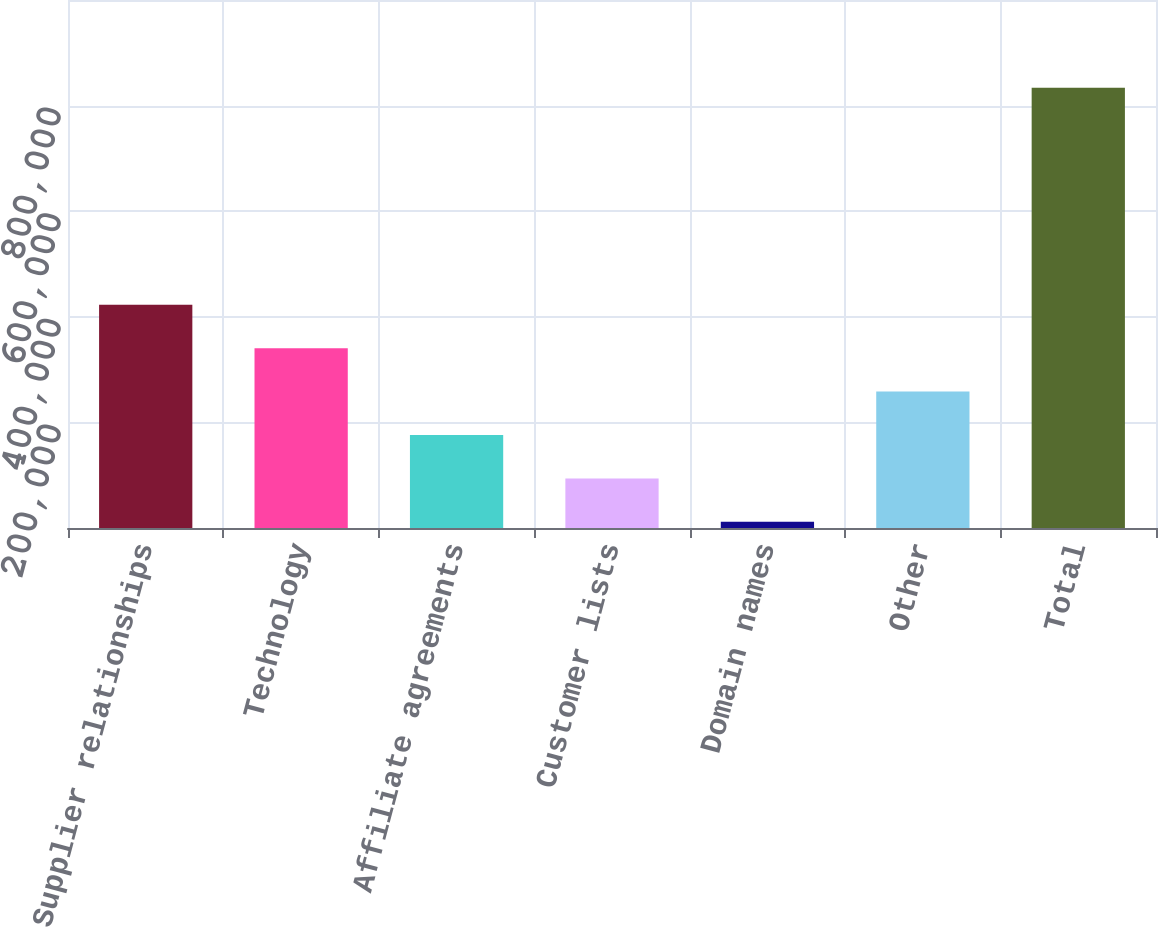Convert chart. <chart><loc_0><loc_0><loc_500><loc_500><bar_chart><fcel>Supplier relationships<fcel>Technology<fcel>Affiliate agreements<fcel>Customer lists<fcel>Domain names<fcel>Other<fcel>Total<nl><fcel>422706<fcel>340501<fcel>176089<fcel>93883.7<fcel>11678<fcel>258295<fcel>833735<nl></chart> 